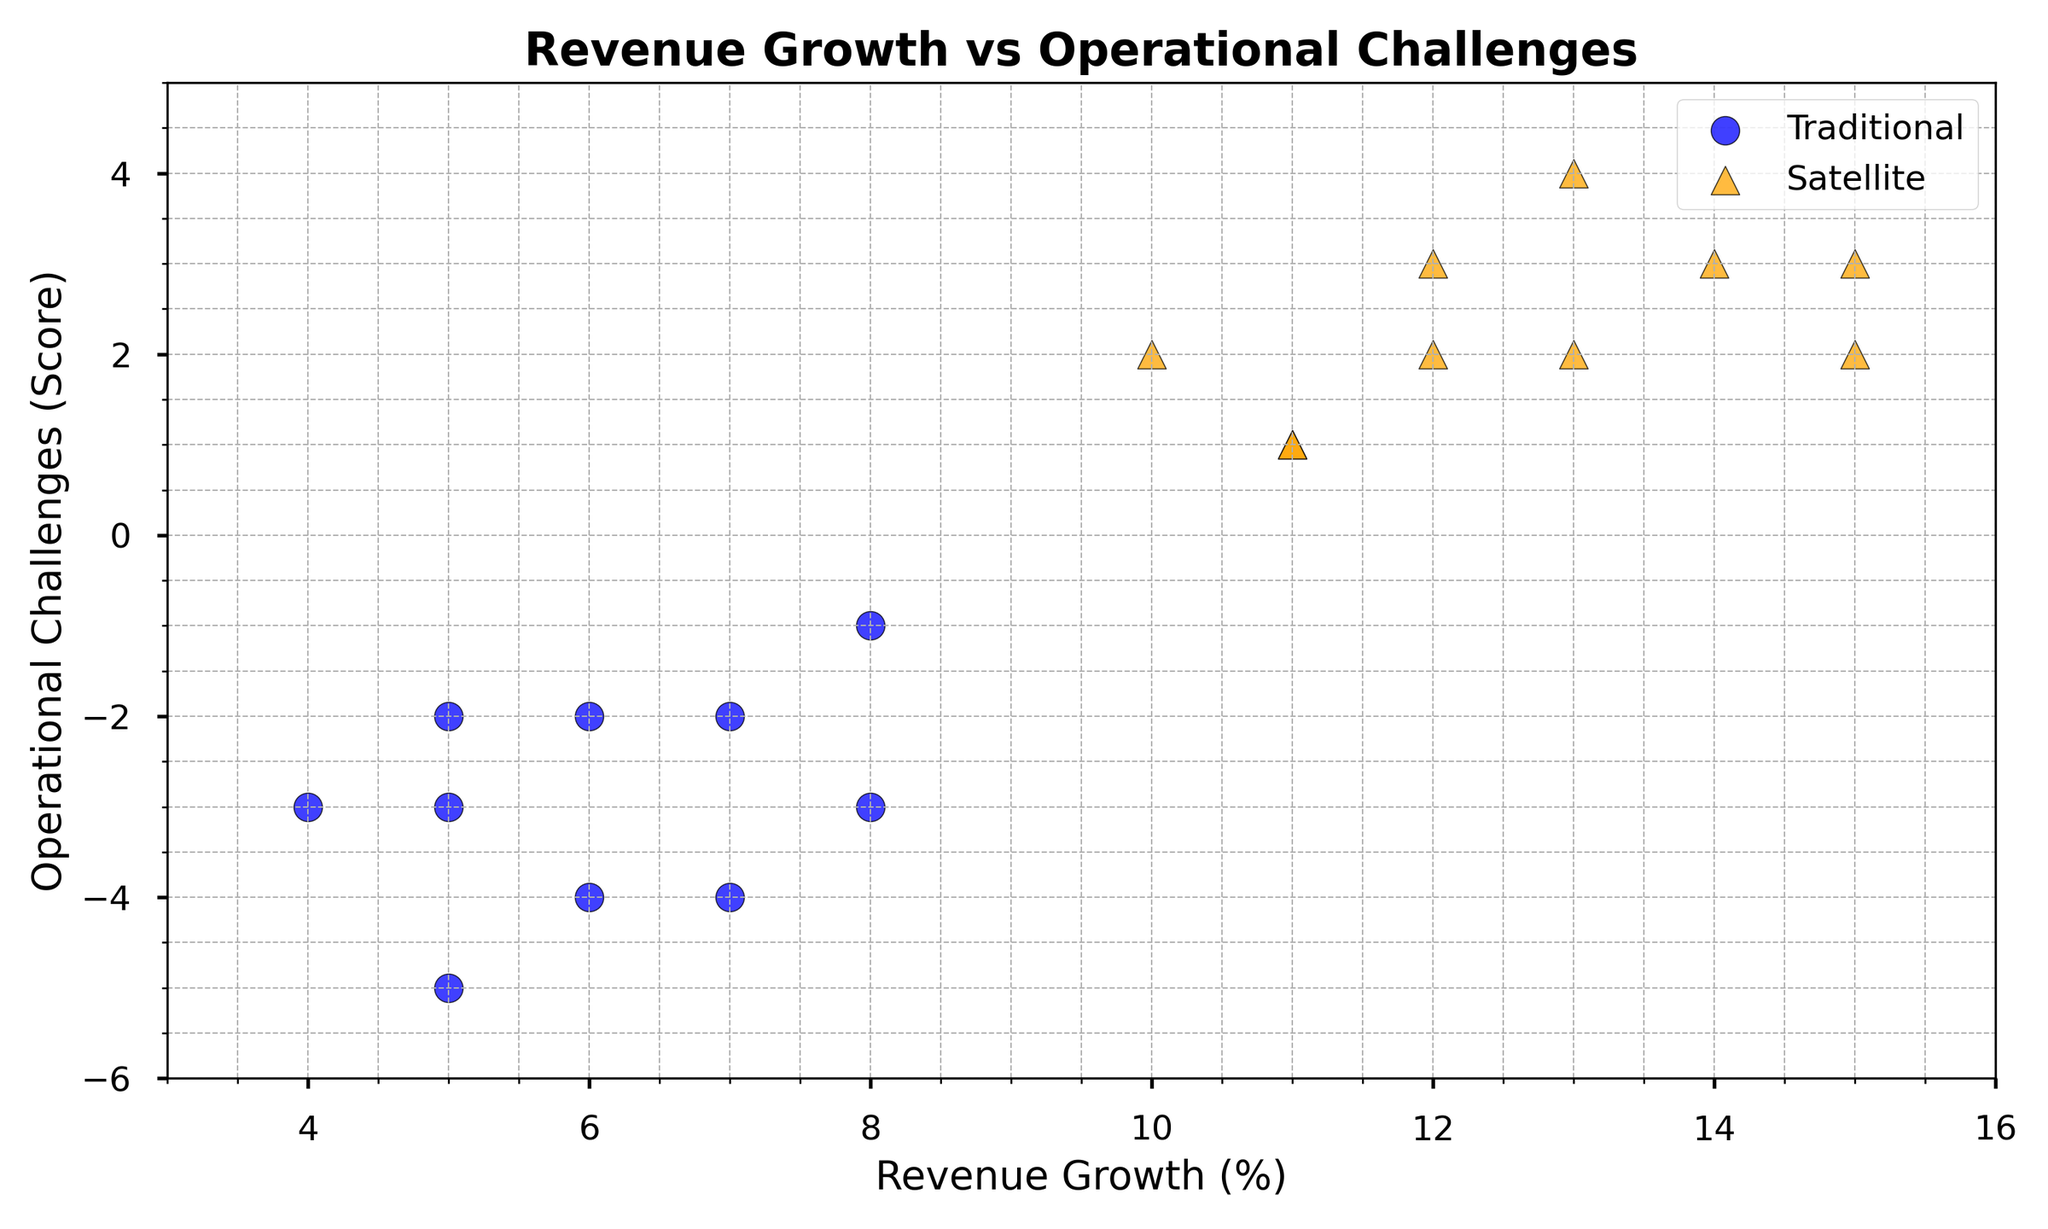What's the average revenue growth for traditional services? The revenue growth for traditional services is listed as 5, 7, 6, 8, 5, 4, 6, 7, 8, 5. Adding these values gives 61, and there are 10 data points. So, the average revenue growth is 61/10 = 6.1
Answer: 6.1 Comparing the highest operational challenge, which service type has the greater value? The highest operational challenge for traditional services is -1, while for satellite-based services, it is 4. Therefore, the highest operational challenge value is higher for satellite-based services.
Answer: Satellite-based What is the range of operational challenges for satellite services? The minimum operational challenge for satellite services is 1 and the maximum is 4. The range is calculated as the difference between the maximum and minimum values, which is 4 - 1 = 3.
Answer: 3 By comparing the average operational challenge for both service types, which one has a lower value? The operational challenges for traditional services are: -3, -2, -4, -1, -5, -3, -2, -4, -3, -2. Summing these up gives -29, and the average is -29/10 = -2.9. For satellite, the values are 2, 3, 1, 4, 2, 3, 1, 2, 2, 3. Summing these gives 23, and the average is 23/10 = 2.3. Thus, traditional services have a lower average operational challenge.
Answer: Traditional What is the total revenue growth for satellite services? The revenue growth for satellite services is listed as 10, 12, 11, 13, 15, 14, 11, 13, 12, 15. Adding these values gives 126.
Answer: 126 How many service types are plotted on the scatter plot? The plot includes two distinct service types: Traditional and Satellite.
Answer: 2 Which data point represents the highest revenue growth? The highest revenue growth shown on the scatter plot is 15, which is associated with satellite services.
Answer: Satellite What is the median operational challenge value for traditional services? The operational challenges for traditional services are in the range of -5 to -1. Listed in ascending order: -5, -4, -4, -3, -3, -3, -2, -2, -2, -1. The median, the middle value of this ordered list, is -3 (average of the fifth and sixth values).
Answer: -3 Visually, which service type tends to have higher revenue growth? Satellite services are marked by orange triangles, mostly positioned between revenue growth values of 10 to 15, which are higher than the traditional services marked by blue circles mostly positioned between 4 to 8.
Answer: Satellite 